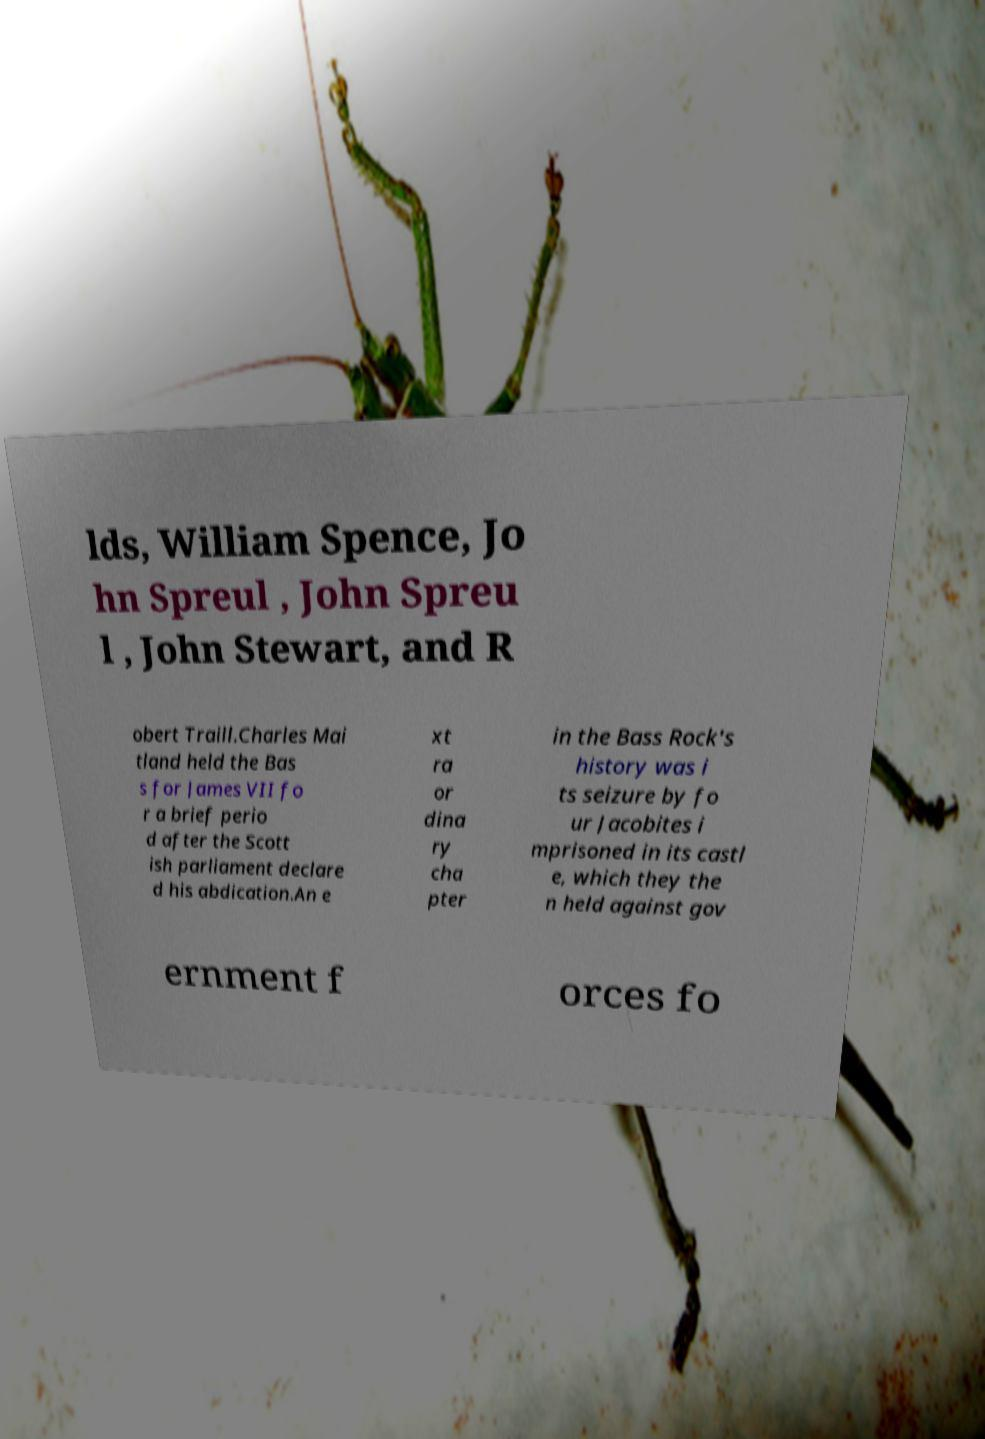Could you assist in decoding the text presented in this image and type it out clearly? lds, William Spence, Jo hn Spreul , John Spreu l , John Stewart, and R obert Traill.Charles Mai tland held the Bas s for James VII fo r a brief perio d after the Scott ish parliament declare d his abdication.An e xt ra or dina ry cha pter in the Bass Rock's history was i ts seizure by fo ur Jacobites i mprisoned in its castl e, which they the n held against gov ernment f orces fo 